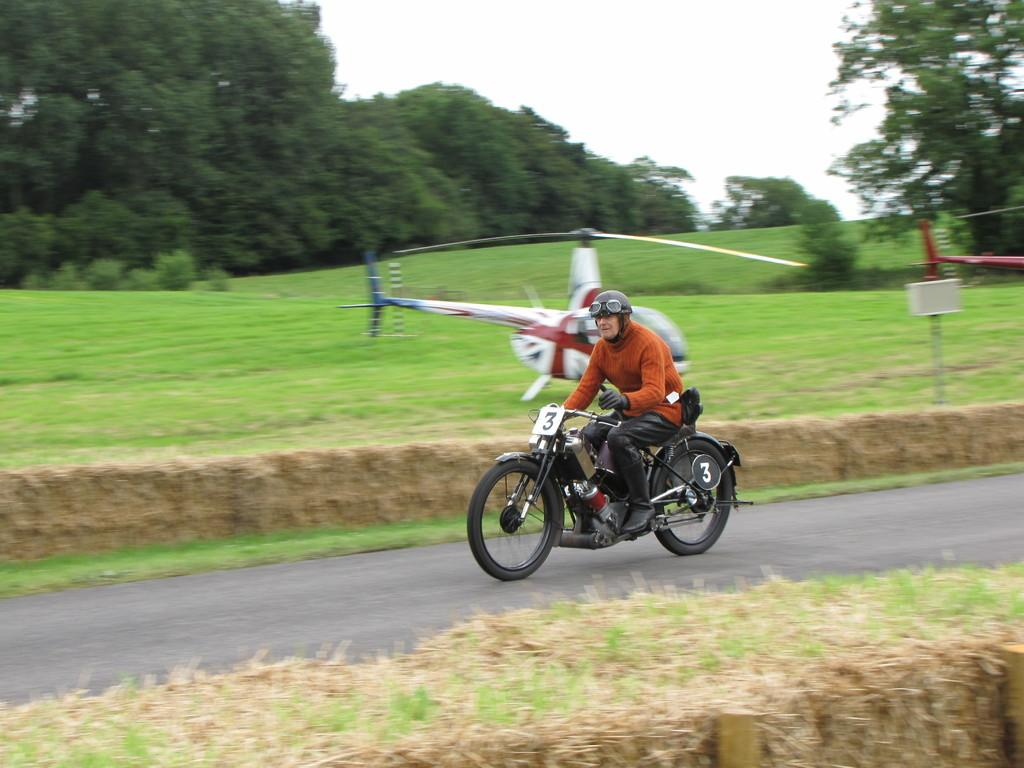What is the person in the image sitting on? The person is sitting on an aircraft. Where is the aircraft located in the image? The aircraft is on the road. What can be seen in the background of the image? There are trees and the sky visible in the background of the image. What type of terrain is present in the image? There is grass in the image. What type of pan is the maid using to cook for the family in the image? There is no pan, maid, or family present in the image. 